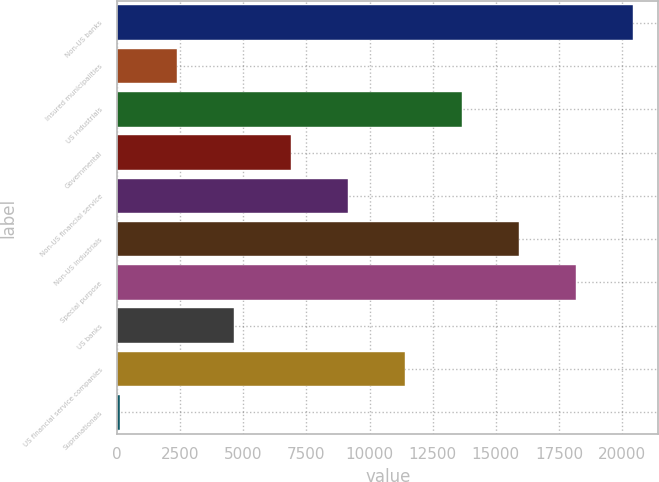Convert chart. <chart><loc_0><loc_0><loc_500><loc_500><bar_chart><fcel>Non-US banks<fcel>Insured municipalities<fcel>US industrials<fcel>Governmental<fcel>Non-US financial service<fcel>Non-US industrials<fcel>Special purpose<fcel>US banks<fcel>US financial service companies<fcel>Supranationals<nl><fcel>20414.4<fcel>2369.6<fcel>13647.6<fcel>6880.8<fcel>9136.4<fcel>15903.2<fcel>18158.8<fcel>4625.2<fcel>11392<fcel>114<nl></chart> 